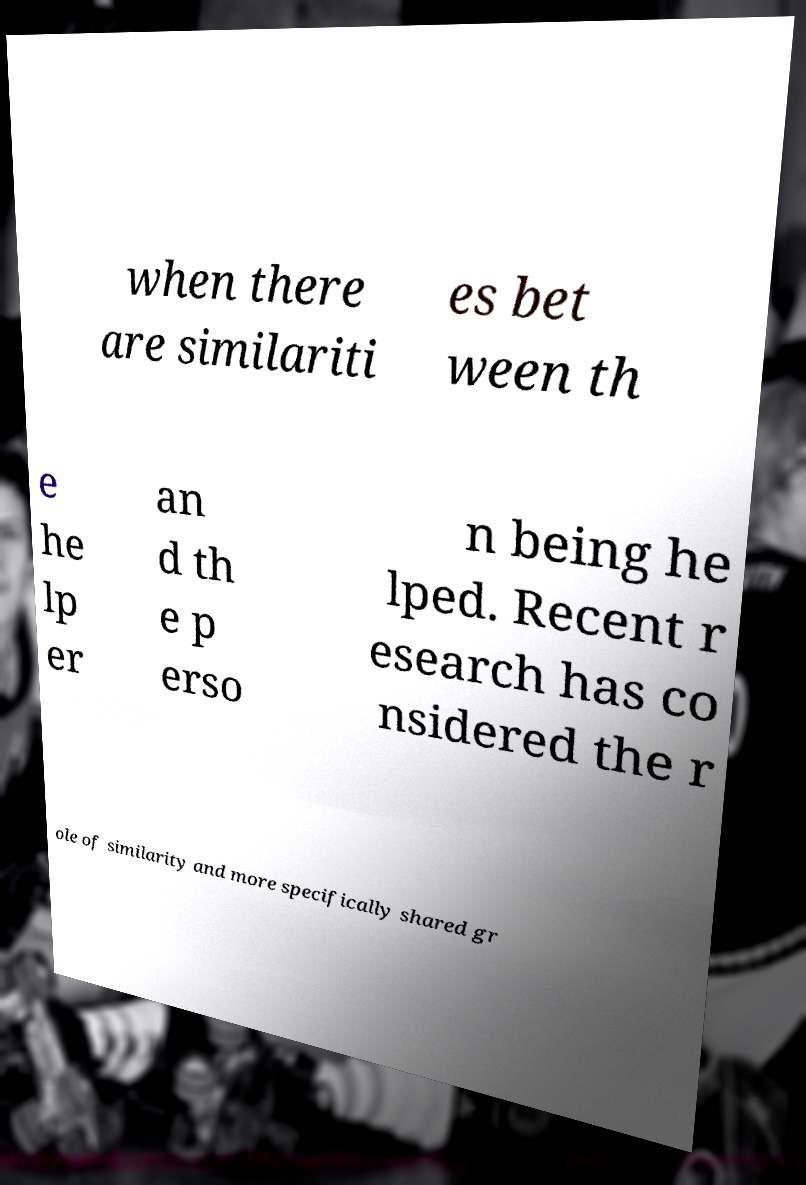Can you read and provide the text displayed in the image?This photo seems to have some interesting text. Can you extract and type it out for me? when there are similariti es bet ween th e he lp er an d th e p erso n being he lped. Recent r esearch has co nsidered the r ole of similarity and more specifically shared gr 